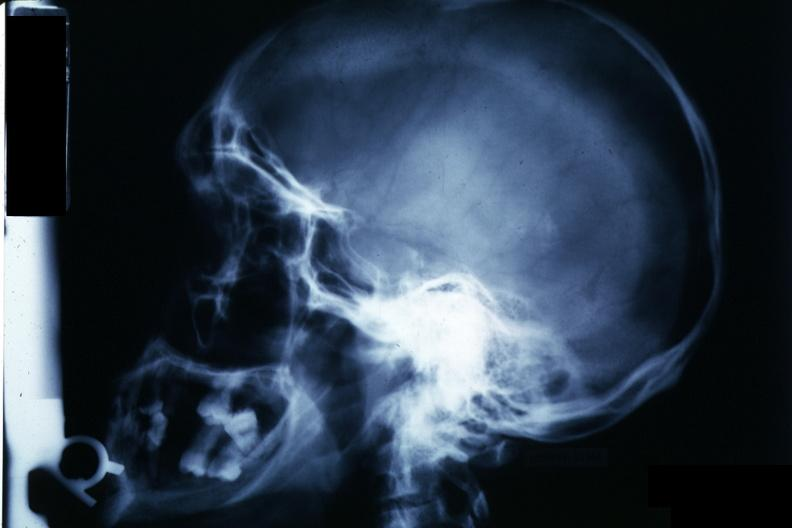s pituitary present?
Answer the question using a single word or phrase. Yes 